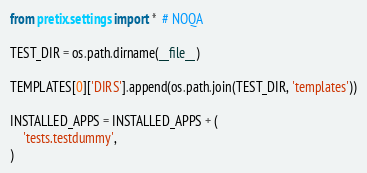Convert code to text. <code><loc_0><loc_0><loc_500><loc_500><_Python_>from pretix.settings import *  # NOQA

TEST_DIR = os.path.dirname(__file__)

TEMPLATES[0]['DIRS'].append(os.path.join(TEST_DIR, 'templates'))

INSTALLED_APPS = INSTALLED_APPS + (
    'tests.testdummy',
)
</code> 